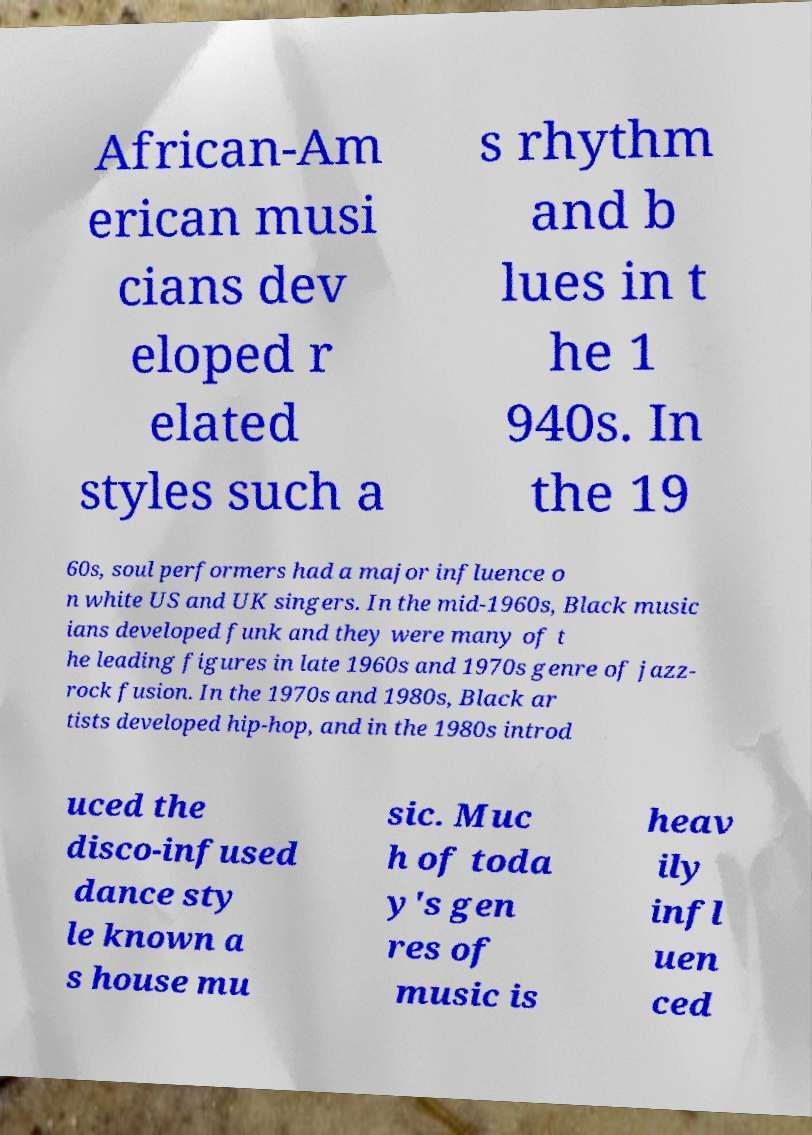Can you accurately transcribe the text from the provided image for me? African-Am erican musi cians dev eloped r elated styles such a s rhythm and b lues in t he 1 940s. In the 19 60s, soul performers had a major influence o n white US and UK singers. In the mid-1960s, Black music ians developed funk and they were many of t he leading figures in late 1960s and 1970s genre of jazz- rock fusion. In the 1970s and 1980s, Black ar tists developed hip-hop, and in the 1980s introd uced the disco-infused dance sty le known a s house mu sic. Muc h of toda y's gen res of music is heav ily infl uen ced 